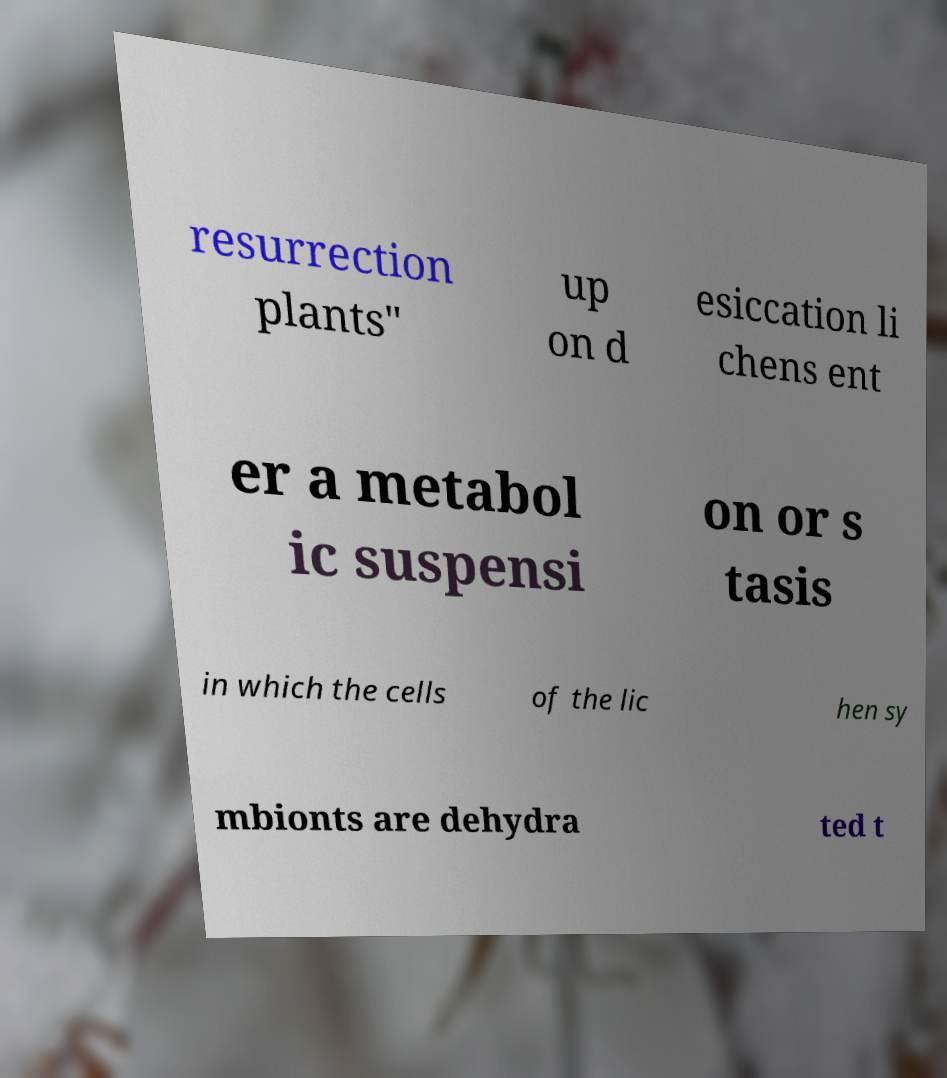Please identify and transcribe the text found in this image. resurrection plants" up on d esiccation li chens ent er a metabol ic suspensi on or s tasis in which the cells of the lic hen sy mbionts are dehydra ted t 